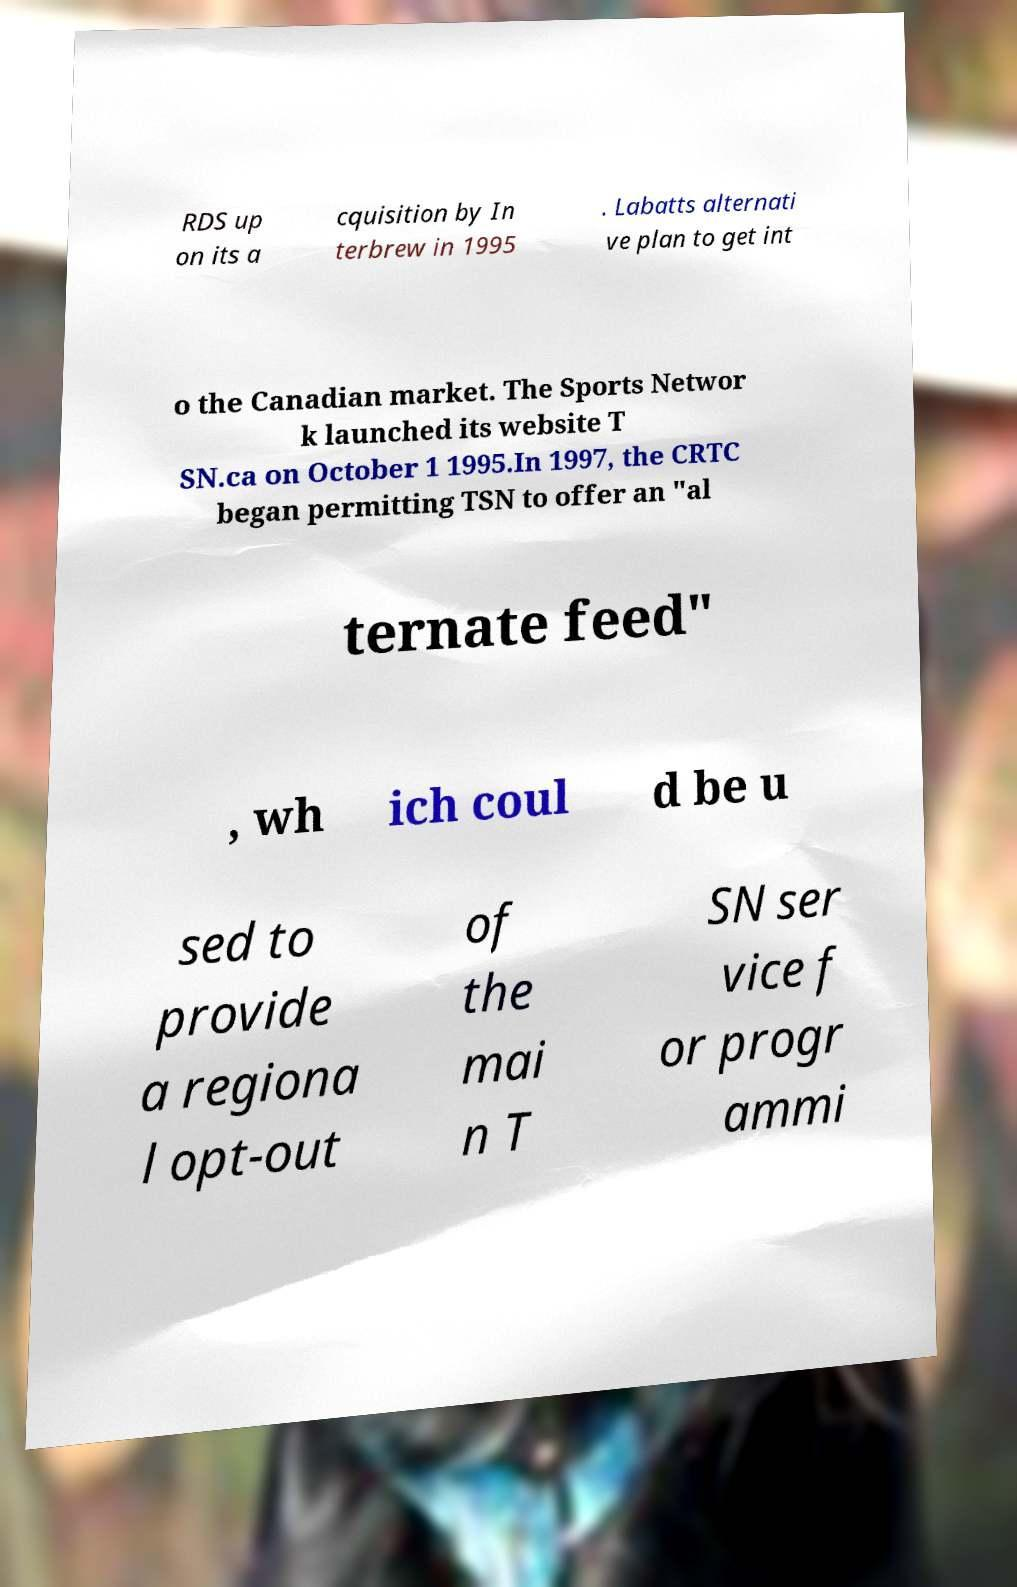Please read and relay the text visible in this image. What does it say? RDS up on its a cquisition by In terbrew in 1995 . Labatts alternati ve plan to get int o the Canadian market. The Sports Networ k launched its website T SN.ca on October 1 1995.In 1997, the CRTC began permitting TSN to offer an "al ternate feed" , wh ich coul d be u sed to provide a regiona l opt-out of the mai n T SN ser vice f or progr ammi 